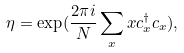Convert formula to latex. <formula><loc_0><loc_0><loc_500><loc_500>\eta = \exp ( \frac { 2 \pi i } { N } \sum _ { x } x c _ { x } ^ { \dagger } c _ { x } ) ,</formula> 